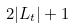<formula> <loc_0><loc_0><loc_500><loc_500>2 | L _ { t } | + 1</formula> 